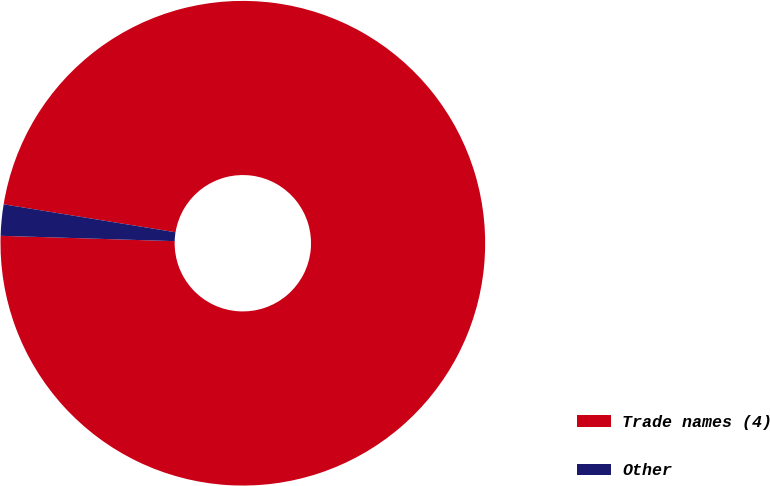Convert chart. <chart><loc_0><loc_0><loc_500><loc_500><pie_chart><fcel>Trade names (4)<fcel>Other<nl><fcel>97.92%<fcel>2.08%<nl></chart> 